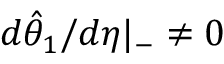Convert formula to latex. <formula><loc_0><loc_0><loc_500><loc_500>d \hat { \theta } _ { 1 } / d \eta | _ { - } \neq 0</formula> 